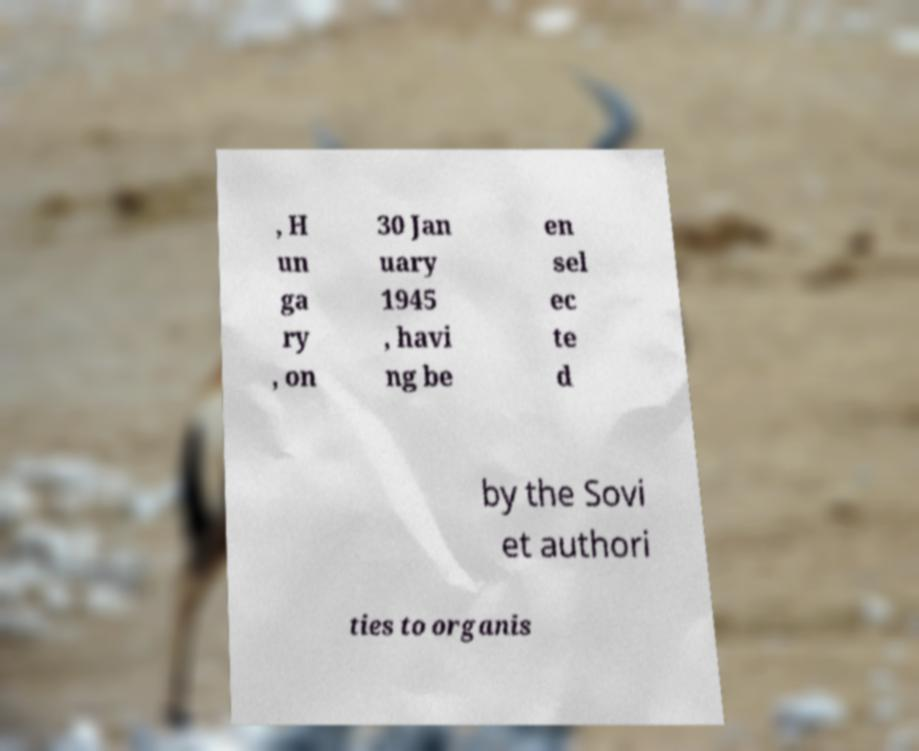Could you assist in decoding the text presented in this image and type it out clearly? , H un ga ry , on 30 Jan uary 1945 , havi ng be en sel ec te d by the Sovi et authori ties to organis 